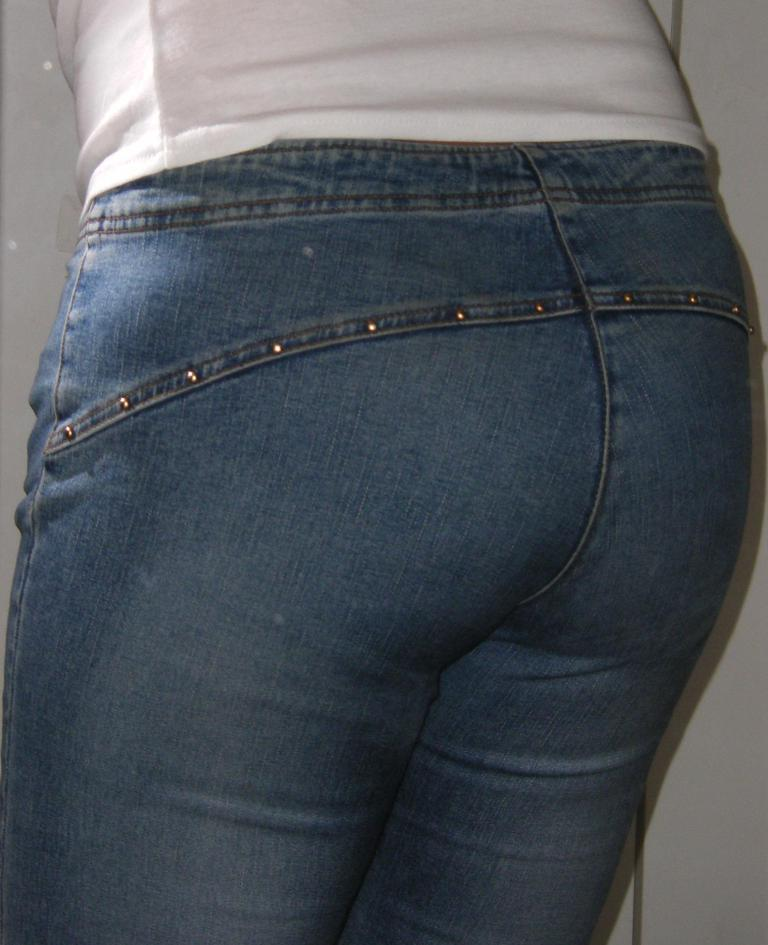What is present in the image? There is a person in the image. What type of clothing is the person wearing? The person is wearing jeans. What type of snails can be seen crawling on the person's jeans in the image? There are no snails present in the image; the person is wearing jeans, but there are no snails visible. 